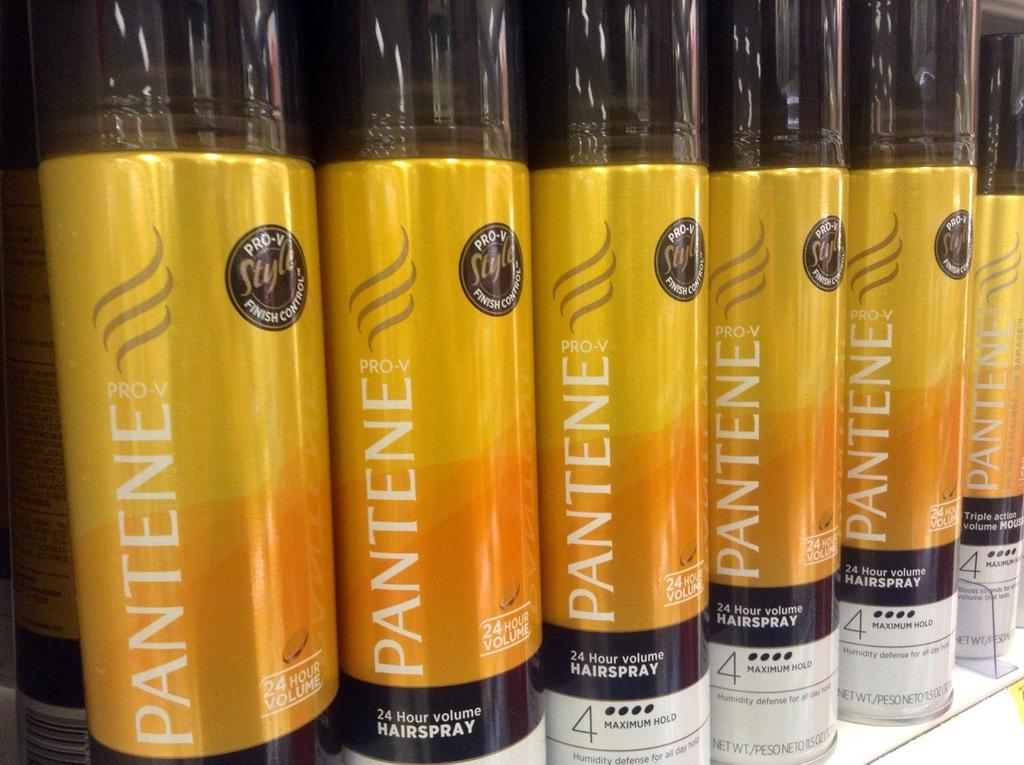<image>
Present a compact description of the photo's key features. Many containers of Pantene hair spray sit on a shelf. 